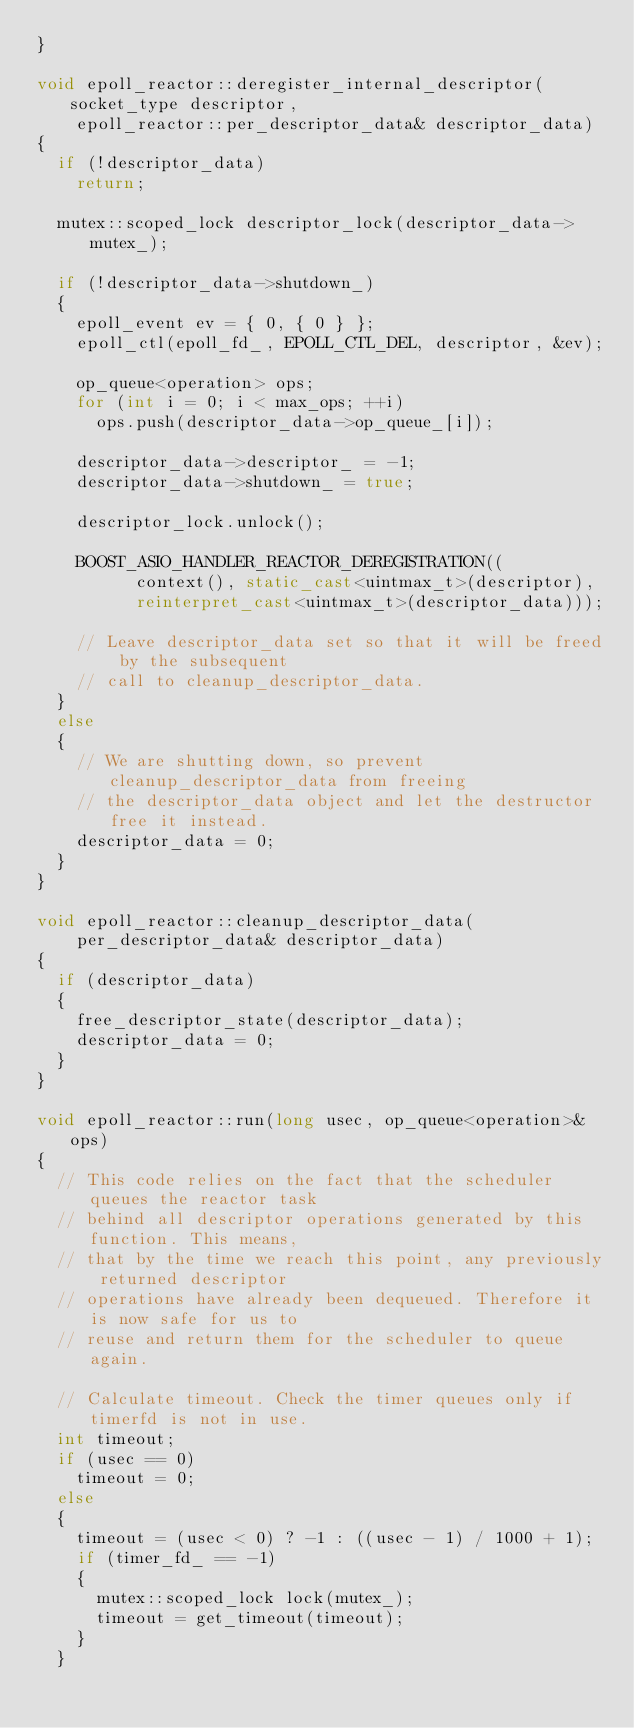<code> <loc_0><loc_0><loc_500><loc_500><_C++_>}

void epoll_reactor::deregister_internal_descriptor(socket_type descriptor,
    epoll_reactor::per_descriptor_data& descriptor_data)
{
  if (!descriptor_data)
    return;

  mutex::scoped_lock descriptor_lock(descriptor_data->mutex_);

  if (!descriptor_data->shutdown_)
  {
    epoll_event ev = { 0, { 0 } };
    epoll_ctl(epoll_fd_, EPOLL_CTL_DEL, descriptor, &ev);

    op_queue<operation> ops;
    for (int i = 0; i < max_ops; ++i)
      ops.push(descriptor_data->op_queue_[i]);

    descriptor_data->descriptor_ = -1;
    descriptor_data->shutdown_ = true;

    descriptor_lock.unlock();

    BOOST_ASIO_HANDLER_REACTOR_DEREGISTRATION((
          context(), static_cast<uintmax_t>(descriptor),
          reinterpret_cast<uintmax_t>(descriptor_data)));

    // Leave descriptor_data set so that it will be freed by the subsequent
    // call to cleanup_descriptor_data.
  }
  else
  {
    // We are shutting down, so prevent cleanup_descriptor_data from freeing
    // the descriptor_data object and let the destructor free it instead.
    descriptor_data = 0;
  }
}

void epoll_reactor::cleanup_descriptor_data(
    per_descriptor_data& descriptor_data)
{
  if (descriptor_data)
  {
    free_descriptor_state(descriptor_data);
    descriptor_data = 0;
  }
}

void epoll_reactor::run(long usec, op_queue<operation>& ops)
{
  // This code relies on the fact that the scheduler queues the reactor task
  // behind all descriptor operations generated by this function. This means,
  // that by the time we reach this point, any previously returned descriptor
  // operations have already been dequeued. Therefore it is now safe for us to
  // reuse and return them for the scheduler to queue again.

  // Calculate timeout. Check the timer queues only if timerfd is not in use.
  int timeout;
  if (usec == 0)
    timeout = 0;
  else
  {
    timeout = (usec < 0) ? -1 : ((usec - 1) / 1000 + 1);
    if (timer_fd_ == -1)
    {
      mutex::scoped_lock lock(mutex_);
      timeout = get_timeout(timeout);
    }
  }
</code> 